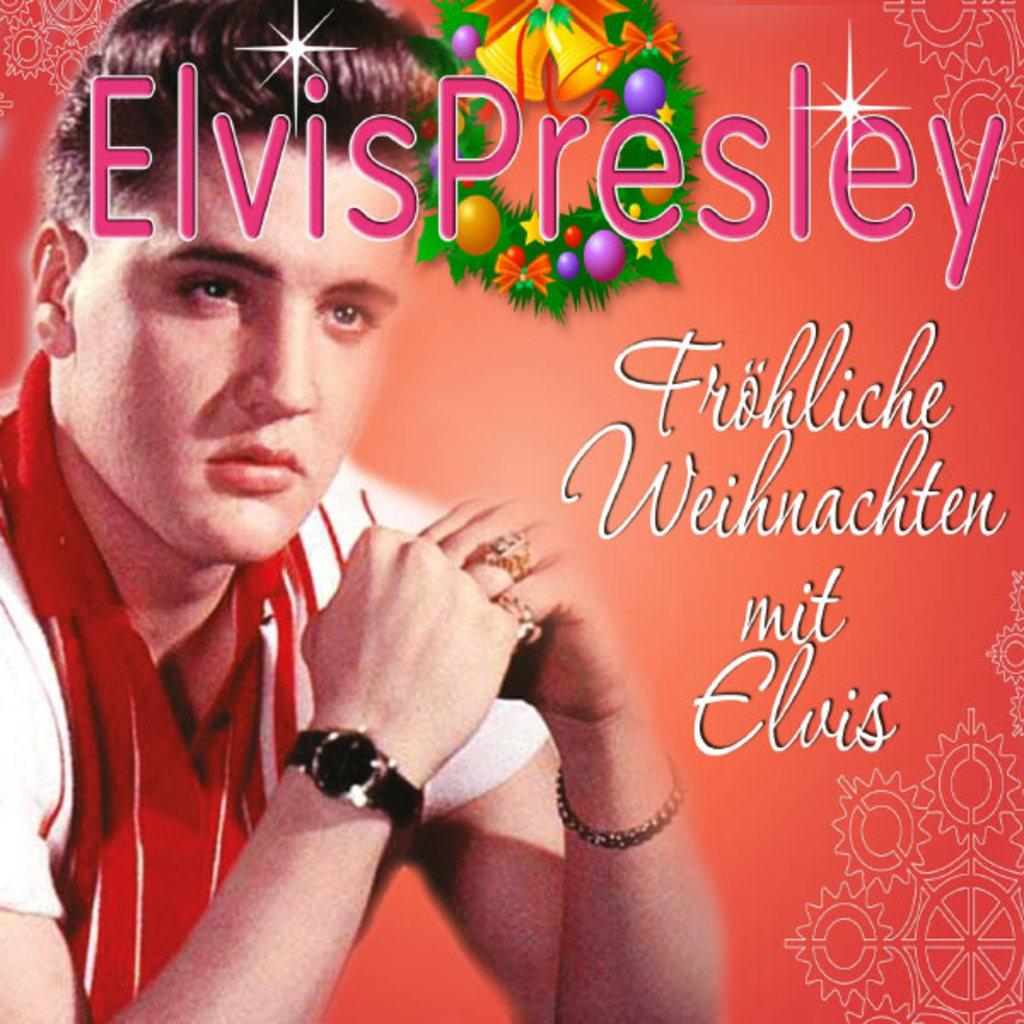What is present in the image? There is a poster in the image. What can be seen on the poster? The poster contains a person wearing a red and white color dress. Are there any words on the poster? Yes, there is text written on the poster. Can you see a turkey walking down a slope on the poster? No, there is no turkey or slope present on the poster; it features a person wearing a red and white dress with text. 